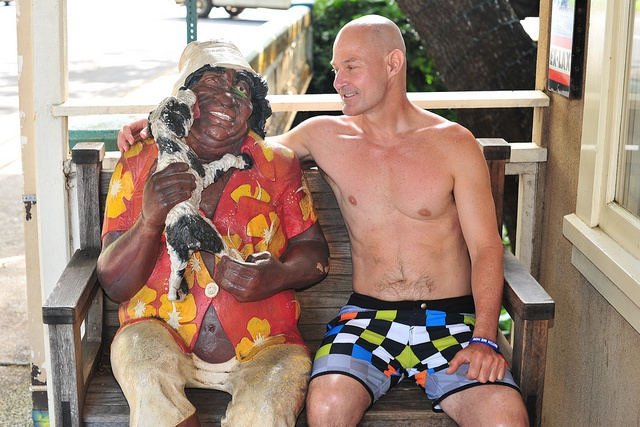Describe the objects in this image and their specific colors. I can see people in gray, salmon, and black tones, people in gray, brown, maroon, and tan tones, bench in gray, black, and darkgray tones, dog in gray, black, darkgray, and lightgray tones, and car in gray, lightgray, and darkgray tones in this image. 